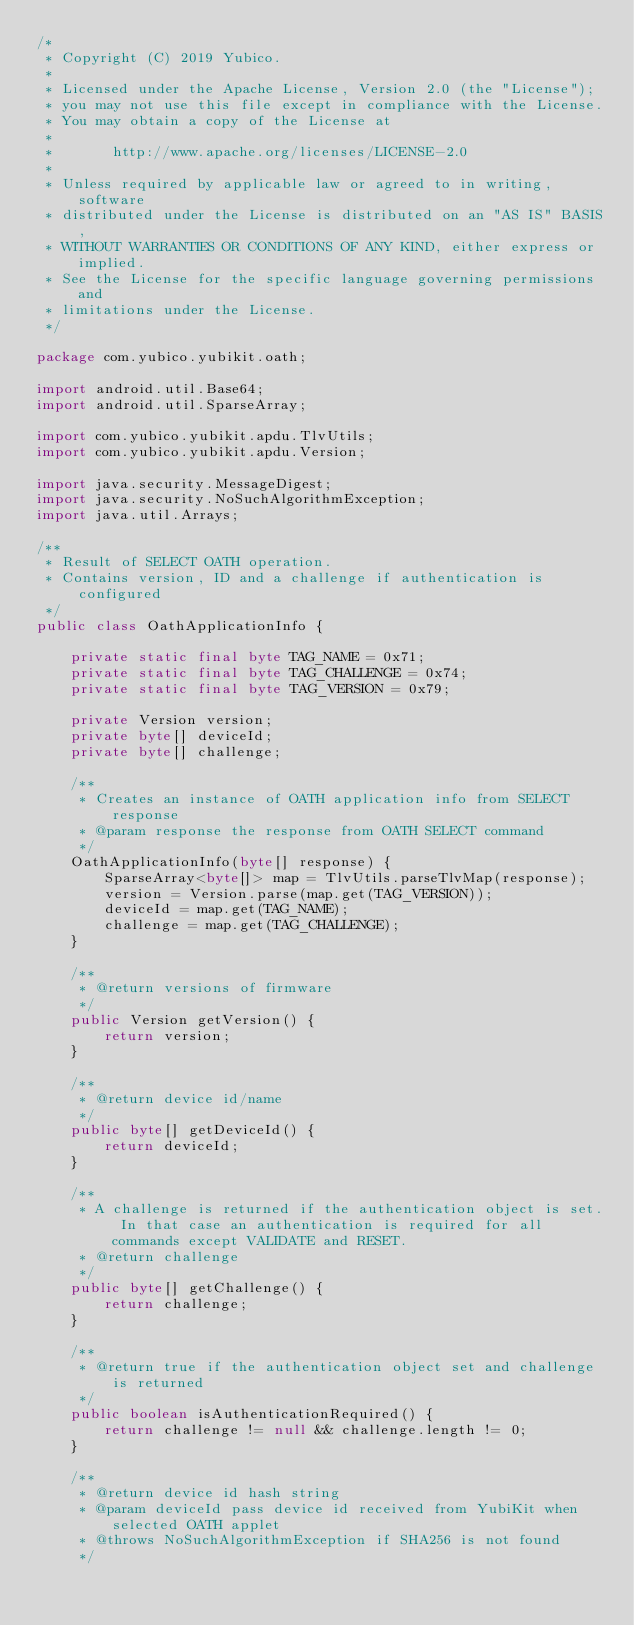Convert code to text. <code><loc_0><loc_0><loc_500><loc_500><_Java_>/*
 * Copyright (C) 2019 Yubico.
 *
 * Licensed under the Apache License, Version 2.0 (the "License");
 * you may not use this file except in compliance with the License.
 * You may obtain a copy of the License at
 *
 *       http://www.apache.org/licenses/LICENSE-2.0
 *
 * Unless required by applicable law or agreed to in writing, software
 * distributed under the License is distributed on an "AS IS" BASIS,
 * WITHOUT WARRANTIES OR CONDITIONS OF ANY KIND, either express or implied.
 * See the License for the specific language governing permissions and
 * limitations under the License.
 */

package com.yubico.yubikit.oath;

import android.util.Base64;
import android.util.SparseArray;

import com.yubico.yubikit.apdu.TlvUtils;
import com.yubico.yubikit.apdu.Version;

import java.security.MessageDigest;
import java.security.NoSuchAlgorithmException;
import java.util.Arrays;

/**
 * Result of SELECT OATH operation.
 * Contains version, ID and a challenge if authentication is configured
 */
public class OathApplicationInfo {

    private static final byte TAG_NAME = 0x71;
    private static final byte TAG_CHALLENGE = 0x74;
    private static final byte TAG_VERSION = 0x79;

    private Version version;
    private byte[] deviceId;
    private byte[] challenge;

    /**
     * Creates an instance of OATH application info from SELECT response
     * @param response the response from OATH SELECT command
     */
    OathApplicationInfo(byte[] response) {
        SparseArray<byte[]> map = TlvUtils.parseTlvMap(response);
        version = Version.parse(map.get(TAG_VERSION));
        deviceId = map.get(TAG_NAME);
        challenge = map.get(TAG_CHALLENGE);
    }

    /**
     * @return versions of firmware
     */
    public Version getVersion() {
        return version;
    }

    /**
     * @return device id/name
     */
    public byte[] getDeviceId() {
        return deviceId;
    }

    /**
     * A challenge is returned if the authentication object is set. In that case an authentication is required for all commands except VALIDATE and RESET.
     * @return challenge
     */
    public byte[] getChallenge() {
        return challenge;
    }

    /**
     * @return true if the authentication object set and challenge is returned
     */
    public boolean isAuthenticationRequired() {
        return challenge != null && challenge.length != 0;
    }

    /**
     * @return device id hash string
     * @param deviceId pass device id received from YubiKit when selected OATH applet
     * @throws NoSuchAlgorithmException if SHA256 is not found
     */</code> 